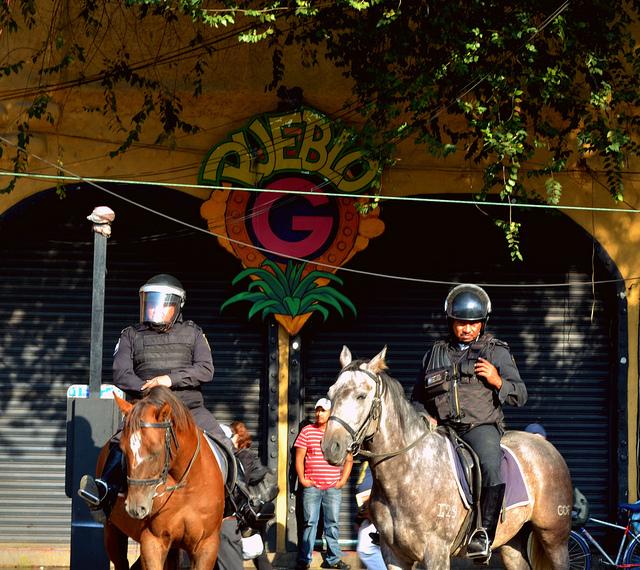What are the riders wearing on their heads?
Answer briefly. Helmets. Are the two horses has the same color?
Give a very brief answer. No. Are these cowboys?
Short answer required. No. 